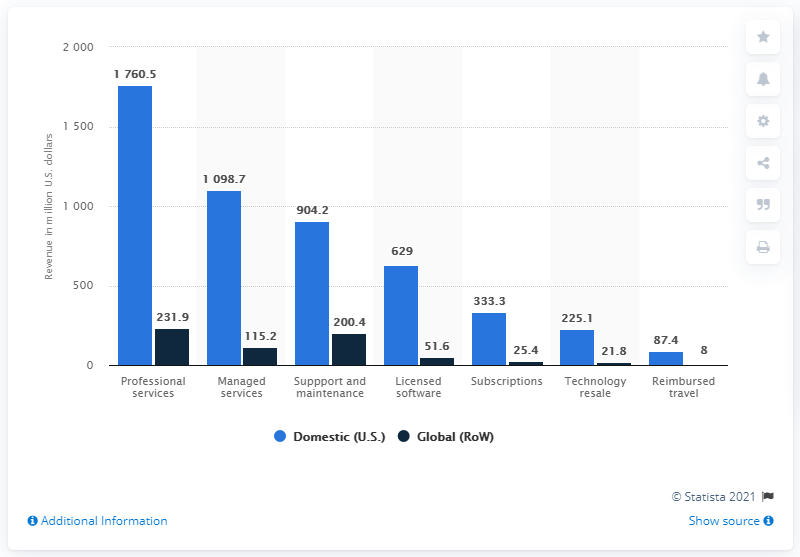Highlight a few significant elements in this photo. In the year 2019, Cerner earned a total of 1,760.5 million dollars in the United States. 